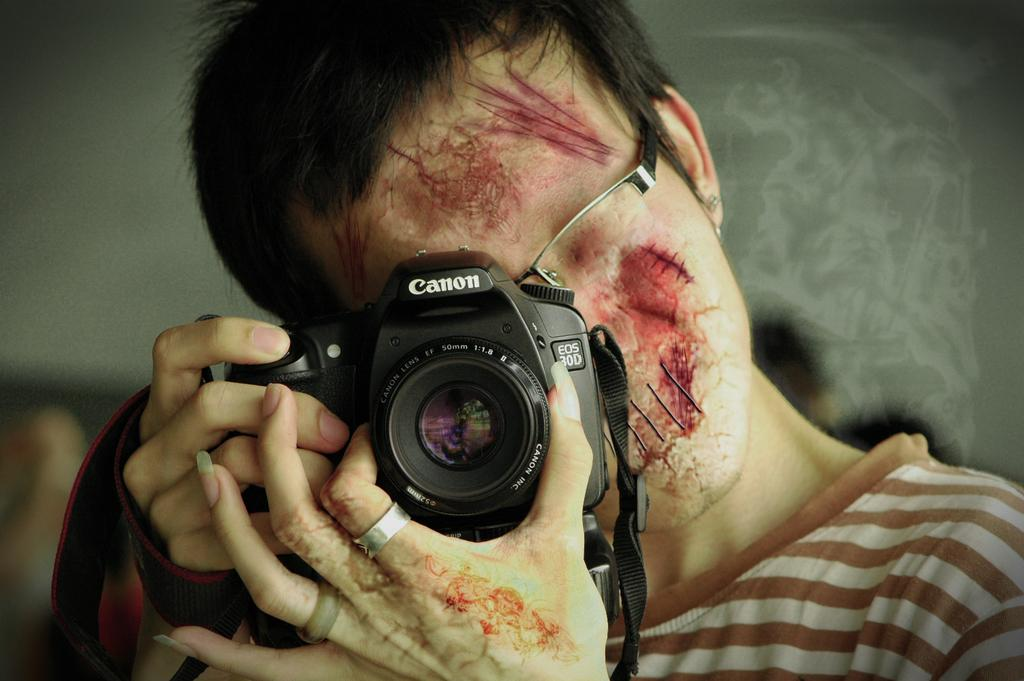What is the woman in the image doing? The woman is taking a picture of herself. What is the woman holding in her hand? The woman holds a camera in her hand. What can be observed on the woman's face? The woman has graphical imitated scars, cuts, and blood stains on her face. What type of clothing is the woman wearing? The woman is wearing a T-shirt with stripes. What type of flower is the fireman holding in the image? There is no fireman or flower present in the image. What type of oil can be seen dripping from the woman's hair in the image? There is no oil or indication of oil in the woman's hair in the image. 